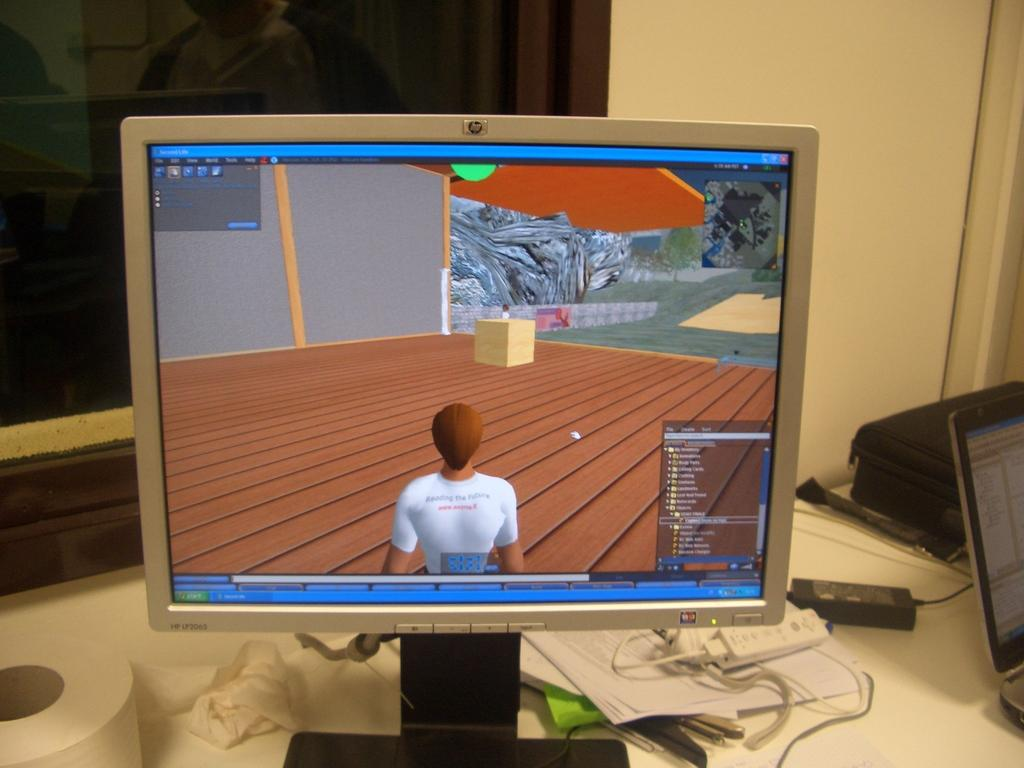Provide a one-sentence caption for the provided image. An old HP monitor sits on a work area next to a newer laptop. 